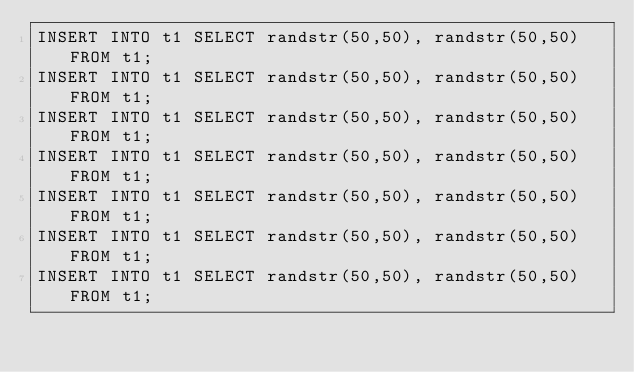Convert code to text. <code><loc_0><loc_0><loc_500><loc_500><_SQL_>INSERT INTO t1 SELECT randstr(50,50), randstr(50,50) FROM t1;
INSERT INTO t1 SELECT randstr(50,50), randstr(50,50) FROM t1;
INSERT INTO t1 SELECT randstr(50,50), randstr(50,50) FROM t1;
INSERT INTO t1 SELECT randstr(50,50), randstr(50,50) FROM t1;
INSERT INTO t1 SELECT randstr(50,50), randstr(50,50) FROM t1;
INSERT INTO t1 SELECT randstr(50,50), randstr(50,50) FROM t1;
INSERT INTO t1 SELECT randstr(50,50), randstr(50,50) FROM t1;</code> 